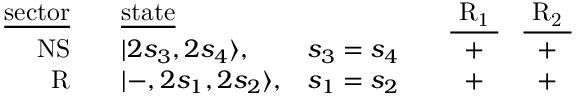<formula> <loc_0><loc_0><loc_500><loc_500>\begin{array} { r c l c c c c } { { \underline { s e c t o r } } } & { { \underline { s t a t e } } } & { { \underline { { { R _ { 1 } } } } } } & { { \underline { { { R _ { 2 } } } } } } \\ { N S } & { { | 2 s _ { 3 } , 2 s _ { 4 } \rangle , } } & { { s _ { 3 } = s _ { 4 } } } & { + } & { + } \\ { R } & { { | - , 2 s _ { 1 } , 2 s _ { 2 } \rangle , } } & { { s _ { 1 } = s _ { 2 } } } & { + } & { + } \end{array}</formula> 